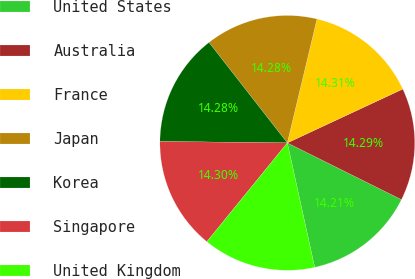Convert chart to OTSL. <chart><loc_0><loc_0><loc_500><loc_500><pie_chart><fcel>United States<fcel>Australia<fcel>France<fcel>Japan<fcel>Korea<fcel>Singapore<fcel>United Kingdom<nl><fcel>14.21%<fcel>14.29%<fcel>14.31%<fcel>14.28%<fcel>14.28%<fcel>14.3%<fcel>14.32%<nl></chart> 